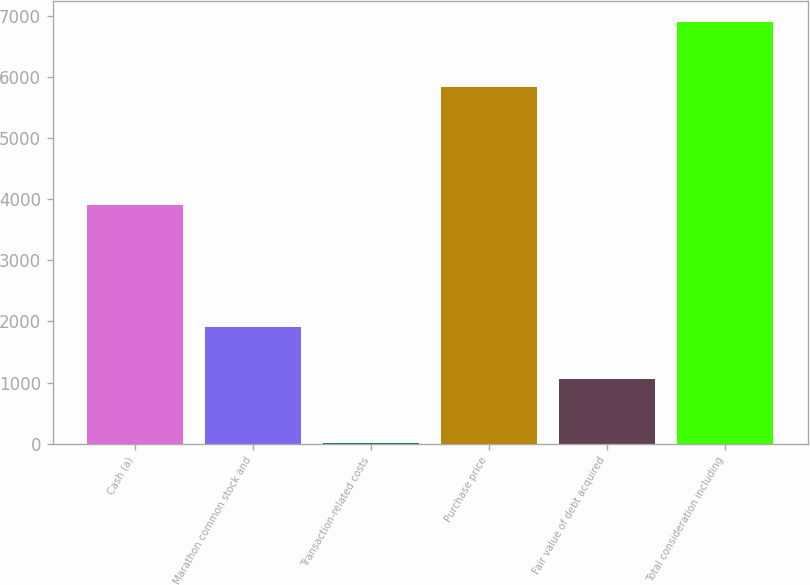Convert chart. <chart><loc_0><loc_0><loc_500><loc_500><bar_chart><fcel>Cash (a)<fcel>Marathon common stock and<fcel>Transaction-related costs<fcel>Purchase price<fcel>Fair value of debt acquired<fcel>Total consideration including<nl><fcel>3907<fcel>1910<fcel>16<fcel>5833<fcel>1063<fcel>6896<nl></chart> 